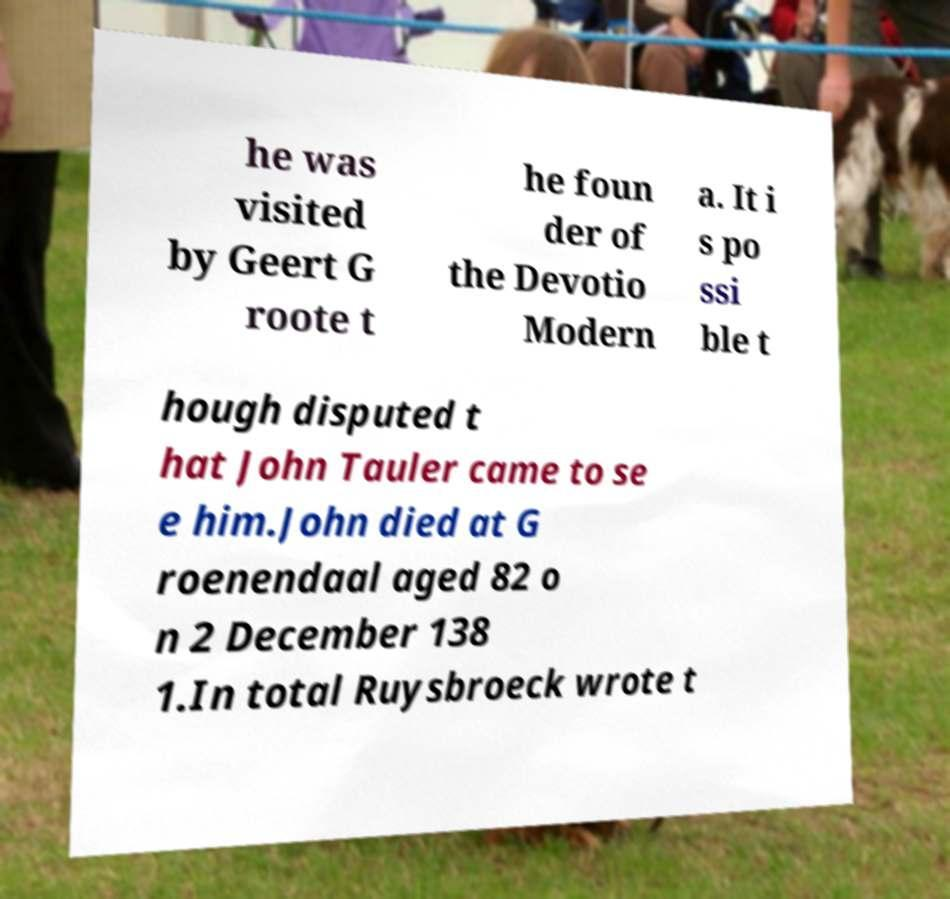Please read and relay the text visible in this image. What does it say? he was visited by Geert G roote t he foun der of the Devotio Modern a. It i s po ssi ble t hough disputed t hat John Tauler came to se e him.John died at G roenendaal aged 82 o n 2 December 138 1.In total Ruysbroeck wrote t 